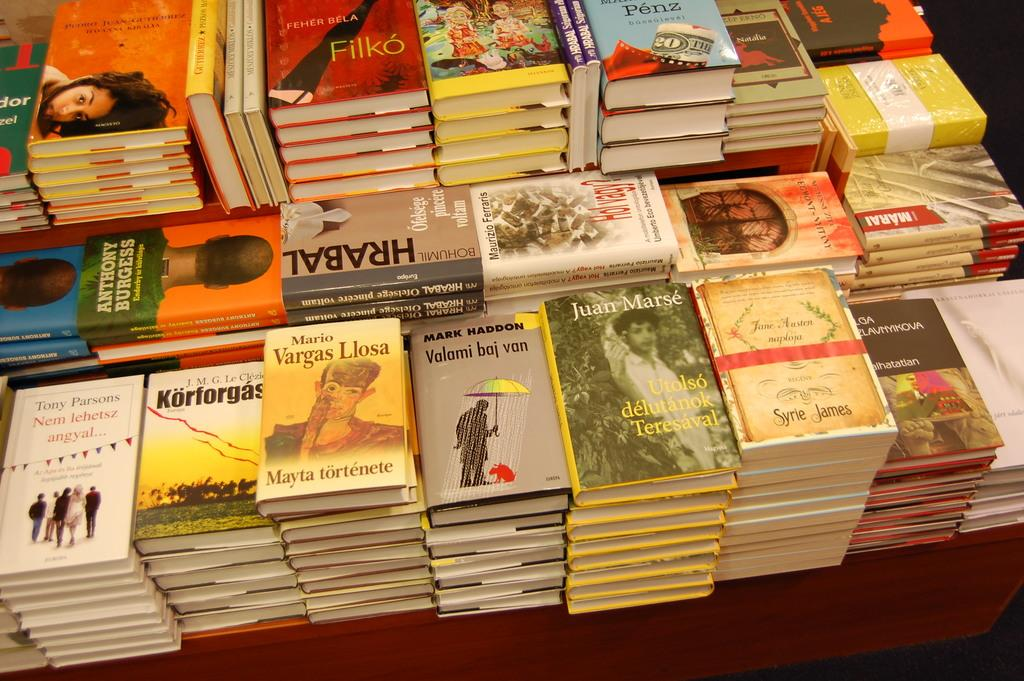<image>
Describe the image concisely. A stack of books by Mark Haddon is surrounded by stacks of other books. 